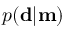Convert formula to latex. <formula><loc_0><loc_0><loc_500><loc_500>p ( d | m )</formula> 